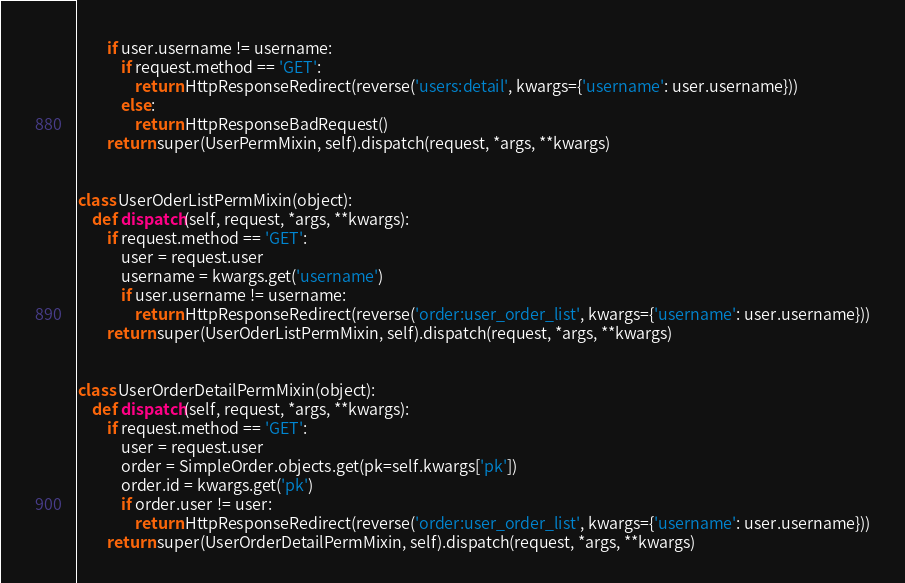Convert code to text. <code><loc_0><loc_0><loc_500><loc_500><_Python_>        if user.username != username:
            if request.method == 'GET':
                return HttpResponseRedirect(reverse('users:detail', kwargs={'username': user.username}))
            else:
                return HttpResponseBadRequest()
        return super(UserPermMixin, self).dispatch(request, *args, **kwargs)


class UserOderListPermMixin(object):
    def dispatch(self, request, *args, **kwargs):
        if request.method == 'GET':
            user = request.user
            username = kwargs.get('username')
            if user.username != username:
                return HttpResponseRedirect(reverse('order:user_order_list', kwargs={'username': user.username}))
        return super(UserOderListPermMixin, self).dispatch(request, *args, **kwargs)


class UserOrderDetailPermMixin(object):
    def dispatch(self, request, *args, **kwargs):
        if request.method == 'GET':
            user = request.user
            order = SimpleOrder.objects.get(pk=self.kwargs['pk'])
            order.id = kwargs.get('pk')
            if order.user != user:
                return HttpResponseRedirect(reverse('order:user_order_list', kwargs={'username': user.username}))
        return super(UserOrderDetailPermMixin, self).dispatch(request, *args, **kwargs)
</code> 